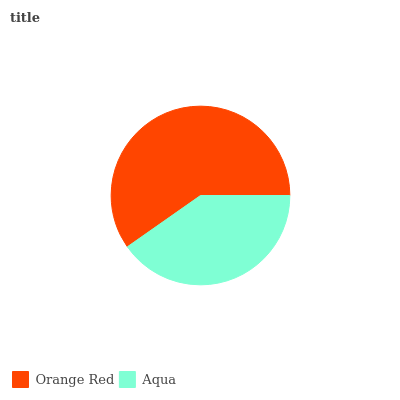Is Aqua the minimum?
Answer yes or no. Yes. Is Orange Red the maximum?
Answer yes or no. Yes. Is Aqua the maximum?
Answer yes or no. No. Is Orange Red greater than Aqua?
Answer yes or no. Yes. Is Aqua less than Orange Red?
Answer yes or no. Yes. Is Aqua greater than Orange Red?
Answer yes or no. No. Is Orange Red less than Aqua?
Answer yes or no. No. Is Orange Red the high median?
Answer yes or no. Yes. Is Aqua the low median?
Answer yes or no. Yes. Is Aqua the high median?
Answer yes or no. No. Is Orange Red the low median?
Answer yes or no. No. 